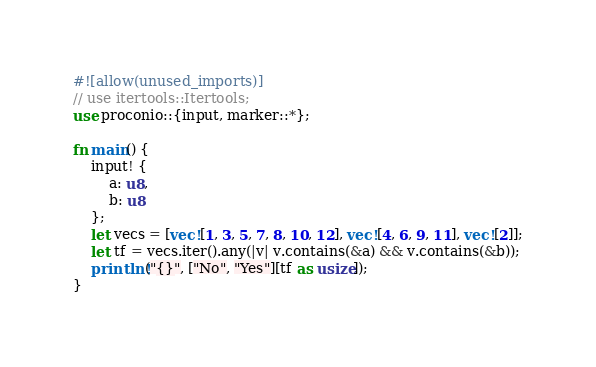Convert code to text. <code><loc_0><loc_0><loc_500><loc_500><_Rust_>#![allow(unused_imports)]
// use itertools::Itertools;
use proconio::{input, marker::*};

fn main() {
    input! {
        a: u8,
        b: u8
    };
    let vecs = [vec![1, 3, 5, 7, 8, 10, 12], vec![4, 6, 9, 11], vec![2]];
    let tf = vecs.iter().any(|v| v.contains(&a) && v.contains(&b));
    println!("{}", ["No", "Yes"][tf as usize]);
}
</code> 